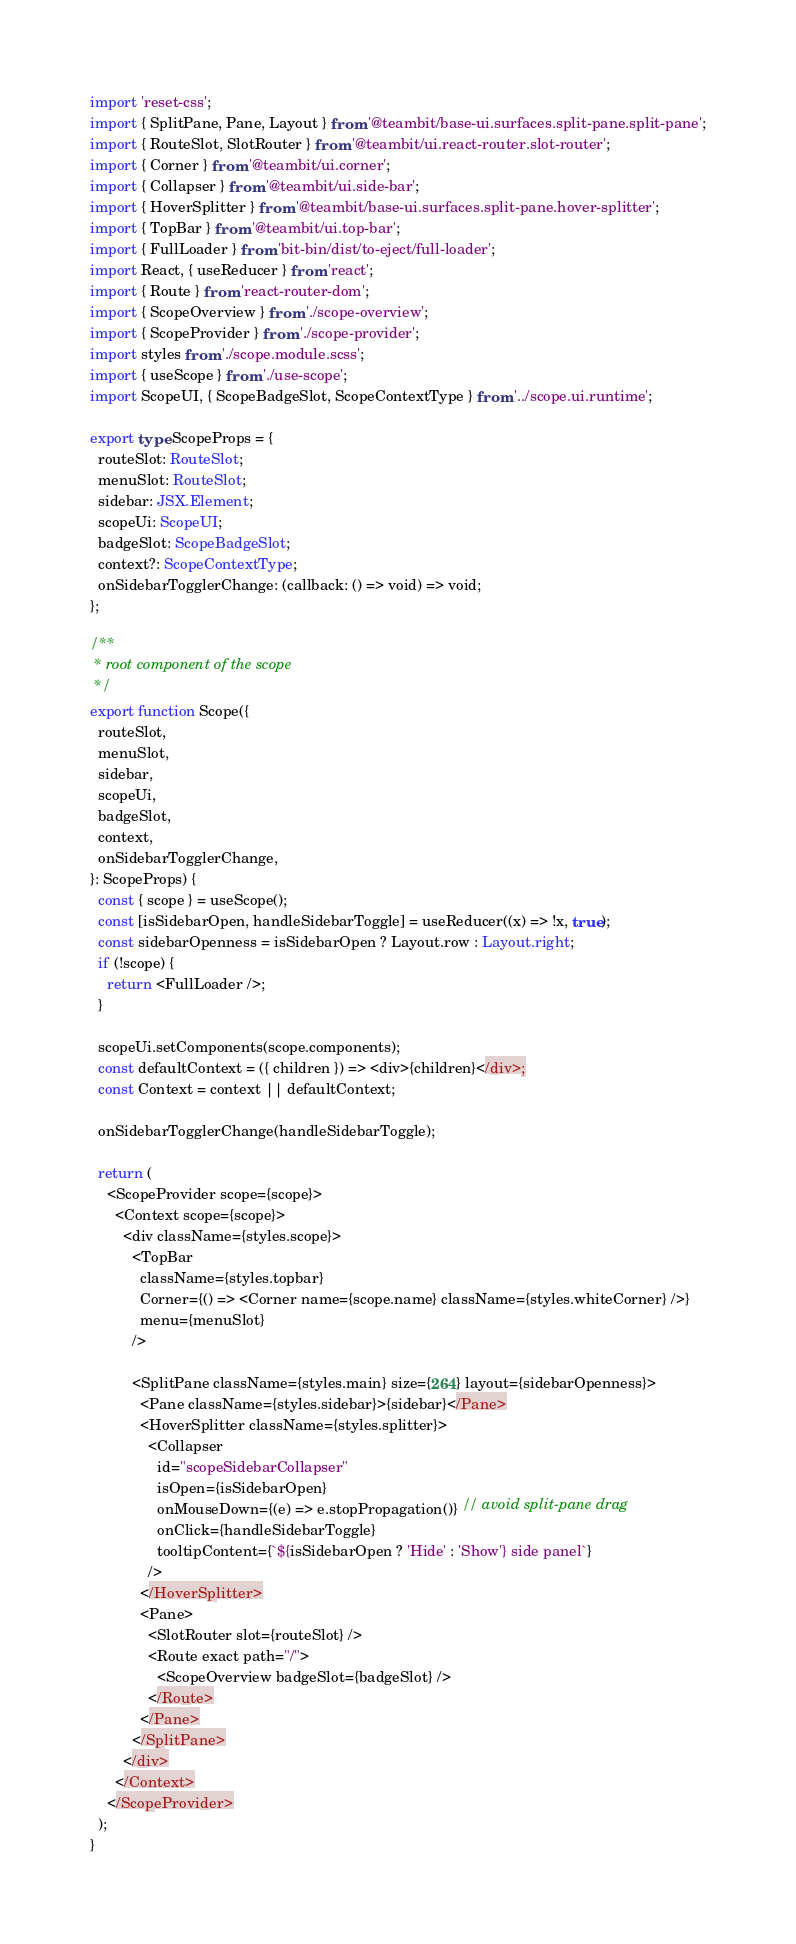Convert code to text. <code><loc_0><loc_0><loc_500><loc_500><_TypeScript_>import 'reset-css';
import { SplitPane, Pane, Layout } from '@teambit/base-ui.surfaces.split-pane.split-pane';
import { RouteSlot, SlotRouter } from '@teambit/ui.react-router.slot-router';
import { Corner } from '@teambit/ui.corner';
import { Collapser } from '@teambit/ui.side-bar';
import { HoverSplitter } from '@teambit/base-ui.surfaces.split-pane.hover-splitter';
import { TopBar } from '@teambit/ui.top-bar';
import { FullLoader } from 'bit-bin/dist/to-eject/full-loader';
import React, { useReducer } from 'react';
import { Route } from 'react-router-dom';
import { ScopeOverview } from './scope-overview';
import { ScopeProvider } from './scope-provider';
import styles from './scope.module.scss';
import { useScope } from './use-scope';
import ScopeUI, { ScopeBadgeSlot, ScopeContextType } from '../scope.ui.runtime';

export type ScopeProps = {
  routeSlot: RouteSlot;
  menuSlot: RouteSlot;
  sidebar: JSX.Element;
  scopeUi: ScopeUI;
  badgeSlot: ScopeBadgeSlot;
  context?: ScopeContextType;
  onSidebarTogglerChange: (callback: () => void) => void;
};

/**
 * root component of the scope
 */
export function Scope({
  routeSlot,
  menuSlot,
  sidebar,
  scopeUi,
  badgeSlot,
  context,
  onSidebarTogglerChange,
}: ScopeProps) {
  const { scope } = useScope();
  const [isSidebarOpen, handleSidebarToggle] = useReducer((x) => !x, true);
  const sidebarOpenness = isSidebarOpen ? Layout.row : Layout.right;
  if (!scope) {
    return <FullLoader />;
  }

  scopeUi.setComponents(scope.components);
  const defaultContext = ({ children }) => <div>{children}</div>;
  const Context = context || defaultContext;

  onSidebarTogglerChange(handleSidebarToggle);

  return (
    <ScopeProvider scope={scope}>
      <Context scope={scope}>
        <div className={styles.scope}>
          <TopBar
            className={styles.topbar}
            Corner={() => <Corner name={scope.name} className={styles.whiteCorner} />}
            menu={menuSlot}
          />

          <SplitPane className={styles.main} size={264} layout={sidebarOpenness}>
            <Pane className={styles.sidebar}>{sidebar}</Pane>
            <HoverSplitter className={styles.splitter}>
              <Collapser
                id="scopeSidebarCollapser"
                isOpen={isSidebarOpen}
                onMouseDown={(e) => e.stopPropagation()} // avoid split-pane drag
                onClick={handleSidebarToggle}
                tooltipContent={`${isSidebarOpen ? 'Hide' : 'Show'} side panel`}
              />
            </HoverSplitter>
            <Pane>
              <SlotRouter slot={routeSlot} />
              <Route exact path="/">
                <ScopeOverview badgeSlot={badgeSlot} />
              </Route>
            </Pane>
          </SplitPane>
        </div>
      </Context>
    </ScopeProvider>
  );
}
</code> 